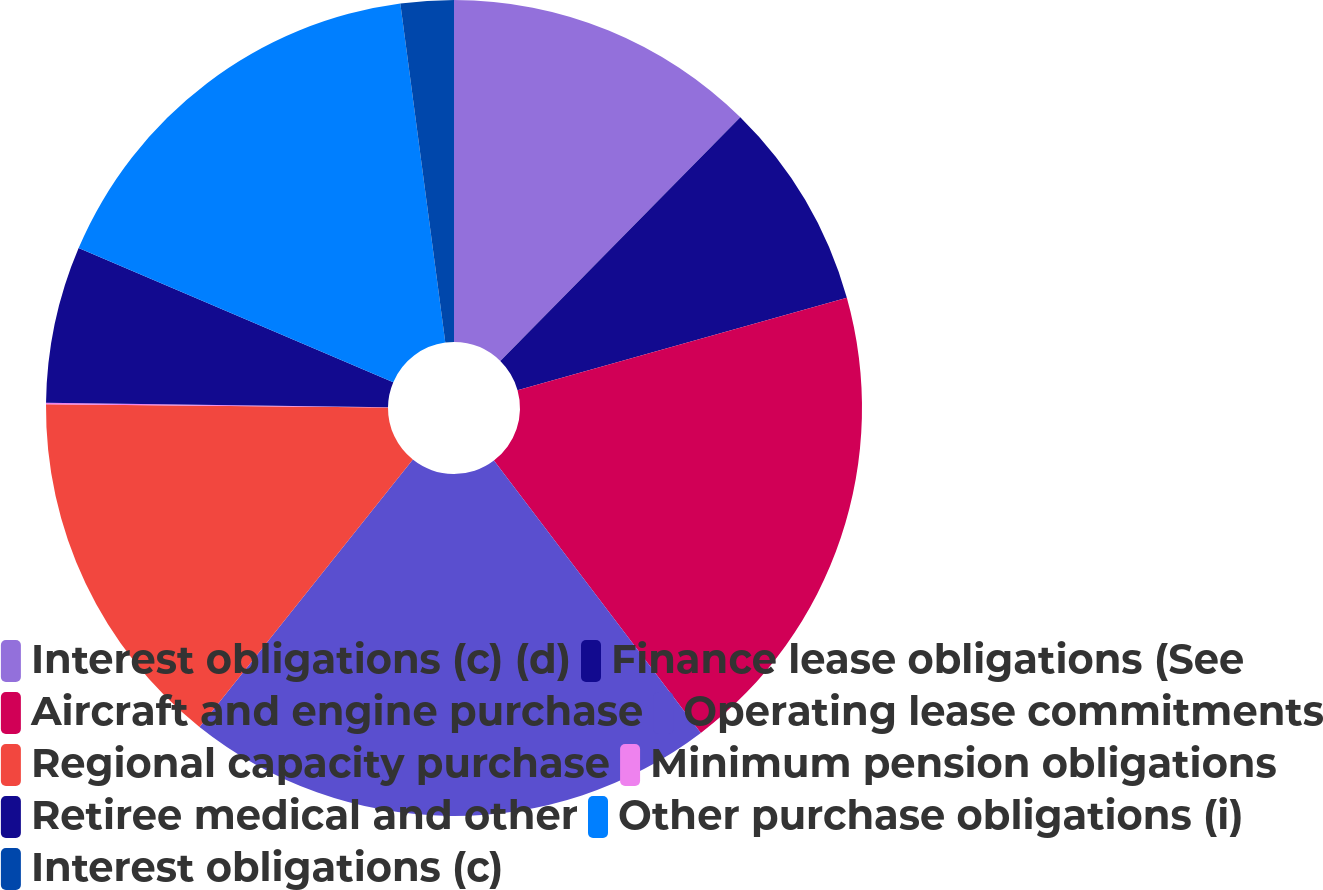Convert chart. <chart><loc_0><loc_0><loc_500><loc_500><pie_chart><fcel>Interest obligations (c) (d)<fcel>Finance lease obligations (See<fcel>Aircraft and engine purchase<fcel>Operating lease commitments<fcel>Regional capacity purchase<fcel>Minimum pension obligations<fcel>Retiree medical and other<fcel>Other purchase obligations (i)<fcel>Interest obligations (c)<nl><fcel>12.38%<fcel>8.27%<fcel>19.01%<fcel>21.06%<fcel>14.43%<fcel>0.05%<fcel>6.21%<fcel>16.49%<fcel>2.1%<nl></chart> 